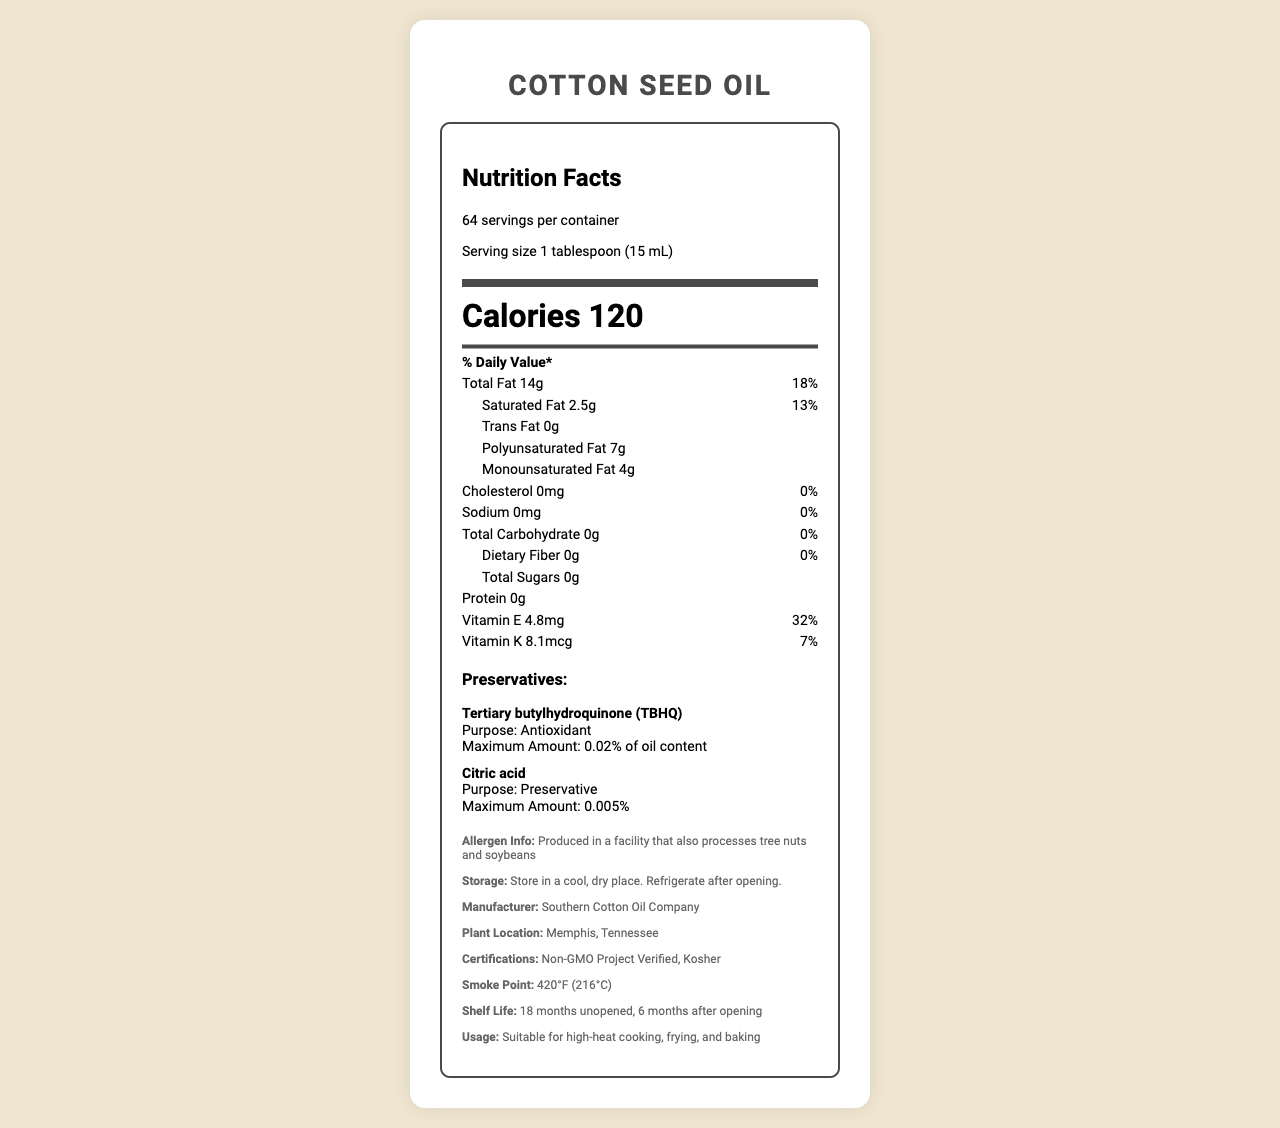what is the serving size for Cotton Seed Oil? The serving size is explicitly stated as "1 tablespoon (15 mL)" in the serving information.
Answer: 1 tablespoon (15 mL) how many calories are in one serving of Cotton Seed Oil? The calorie content per serving is listed as 120 calories in the document.
Answer: 120 what are the preservatives used in Cotton Seed Oil? The preservatives section lists TBHQ and Citric acid along with their purposes and maximum amounts.
Answer: Tertiary butylhydroquinone (TBHQ) and Citric acid how much Vitamin E is in one serving, and what percentage of the daily value does it cover? The document states that one serving contains 4.8mg of Vitamin E, which is 32% of the daily value.
Answer: 4.8mg, 32% is there any cholesterol in Cotton Seed Oil? The document states "Cholesterol 0mg," indicating there is no cholesterol.
Answer: No how many servings are in one container of Cotton Seed Oil? The number of servings per container is mentioned as 64.
Answer: 64 which of the following is not a type of fat listed in the nutrition facts? A. Saturated Fat B. Unsaturated Fat C. Trans Fat D. Polyunsaturated Fat The types of fat listed are Saturated Fat, Trans Fat, and Polyunsaturated Fat. Unsaturated Fat is not listed.
Answer: B what is the daily value percentage of Saturated Fat per serving? A. 5% B. 10% C. 13% D. 20% The daily value percentage of Saturated Fat is listed as 13%.
Answer: C does the Cotton Seed Oil contain any dietary fiber? The document lists dietary fiber as 0g.
Answer: No is the product allergen-free? The allergen information states that it is produced in a facility that processes tree nuts and soybeans.
Answer: No summarize the main nutritional characteristics and additional information of Cotton Seed Oil. The document focuses on the nutritional content, particularly the calorie count from fats, preservatives used, allergen information, and additional usage and storage characteristics.
Answer: Cotton Seed Oil provides 120 calories per serving, primarily from fats, including 14g of total fat, 2.5g saturated fat, and negligible amounts of other macronutrients. It contains preservatives TBHQ and Citric acid. It's produced in a facility that processes tree nuts and soybeans. Additional info includes a smoke point of 420°F, a shelf life of 18 months unopened, and it is suitable for high-heat cooking. what is the main purpose of Tertiary butylhydroquinone (TBHQ) in Cotton Seed Oil? The document specifies TBHQ is used as an "Antioxidant" in the preservatives section.
Answer: Antioxidant what is the sodium content per serving of Cotton Seed Oil? The sodium content per serving is explicitly mentioned as 0mg.
Answer: 0mg which certifications does the Cotton Seed Oil have? The certifications section lists "Non-GMO Project Verified" and "Kosher."
Answer: Non-GMO Project Verified, Kosher can I determine the price of the Cotton Seed Oil from the document? The document does not provide any details about the price.
Answer: Not enough information 